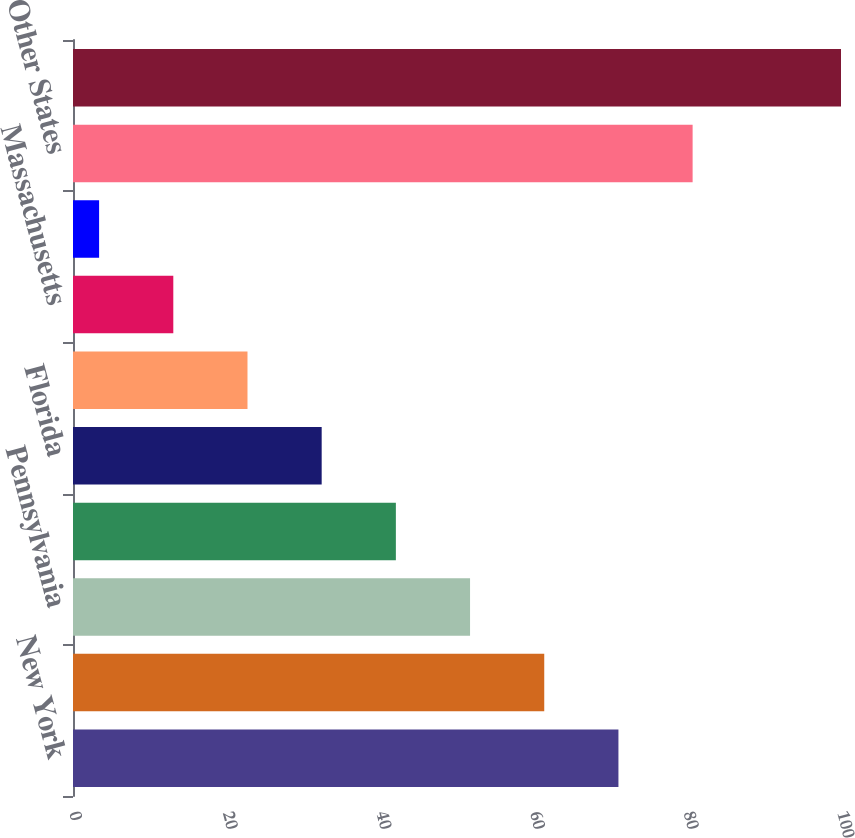Convert chart to OTSL. <chart><loc_0><loc_0><loc_500><loc_500><bar_chart><fcel>New York<fcel>California<fcel>Pennsylvania<fcel>Texas New Jersey<fcel>Florida<fcel>Ohio<fcel>Massachusetts<fcel>Michigan<fcel>Other States<fcel>Total other loans (including<nl><fcel>71.02<fcel>61.36<fcel>51.7<fcel>42.04<fcel>32.38<fcel>22.72<fcel>13.06<fcel>3.4<fcel>80.68<fcel>100<nl></chart> 